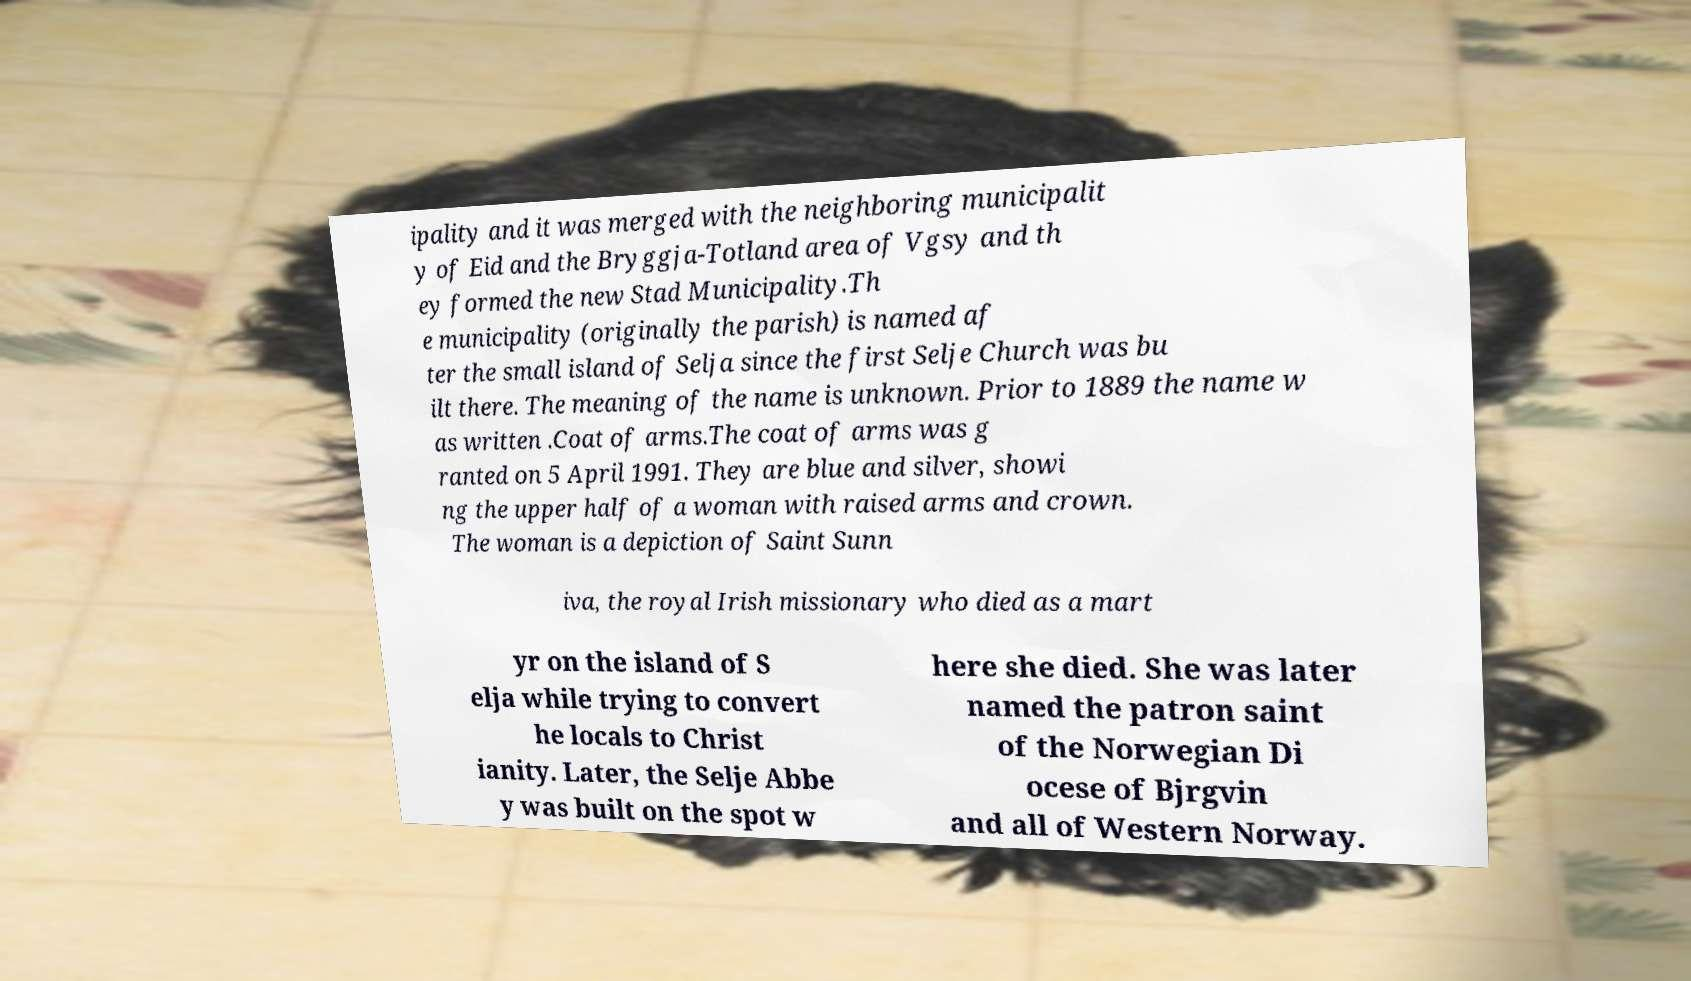There's text embedded in this image that I need extracted. Can you transcribe it verbatim? ipality and it was merged with the neighboring municipalit y of Eid and the Bryggja-Totland area of Vgsy and th ey formed the new Stad Municipality.Th e municipality (originally the parish) is named af ter the small island of Selja since the first Selje Church was bu ilt there. The meaning of the name is unknown. Prior to 1889 the name w as written .Coat of arms.The coat of arms was g ranted on 5 April 1991. They are blue and silver, showi ng the upper half of a woman with raised arms and crown. The woman is a depiction of Saint Sunn iva, the royal Irish missionary who died as a mart yr on the island of S elja while trying to convert he locals to Christ ianity. Later, the Selje Abbe y was built on the spot w here she died. She was later named the patron saint of the Norwegian Di ocese of Bjrgvin and all of Western Norway. 